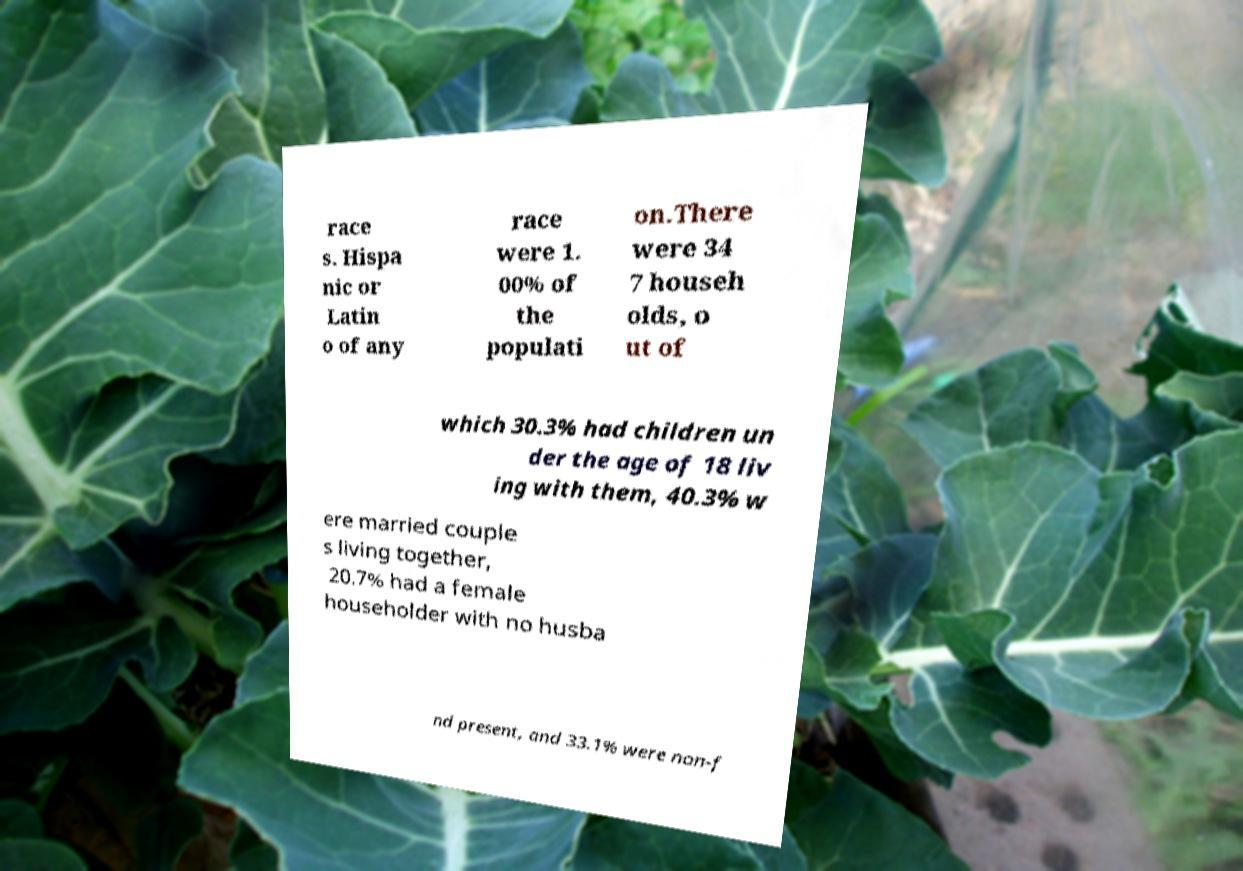I need the written content from this picture converted into text. Can you do that? race s. Hispa nic or Latin o of any race were 1. 00% of the populati on.There were 34 7 househ olds, o ut of which 30.3% had children un der the age of 18 liv ing with them, 40.3% w ere married couple s living together, 20.7% had a female householder with no husba nd present, and 33.1% were non-f 